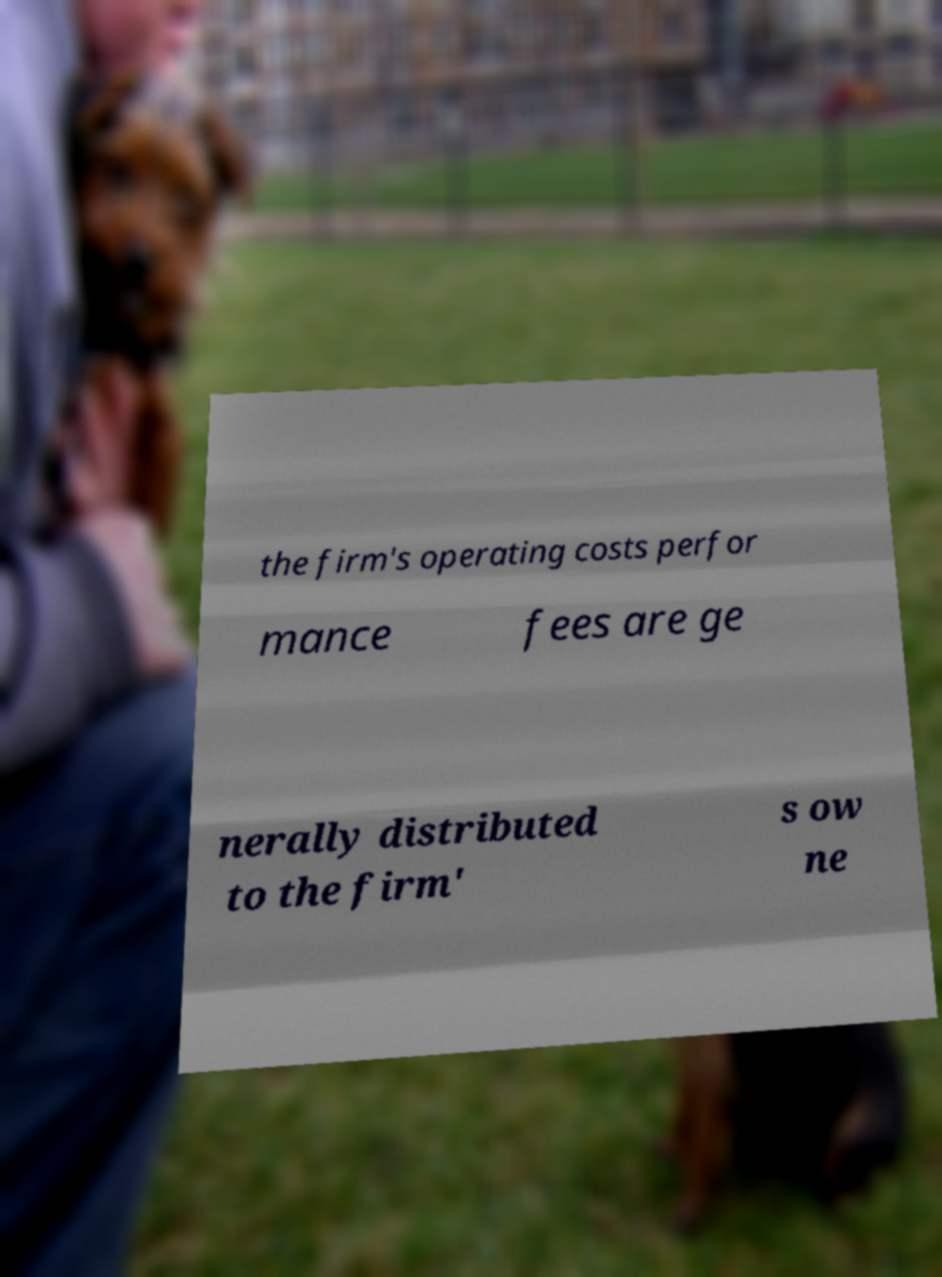There's text embedded in this image that I need extracted. Can you transcribe it verbatim? the firm's operating costs perfor mance fees are ge nerally distributed to the firm' s ow ne 